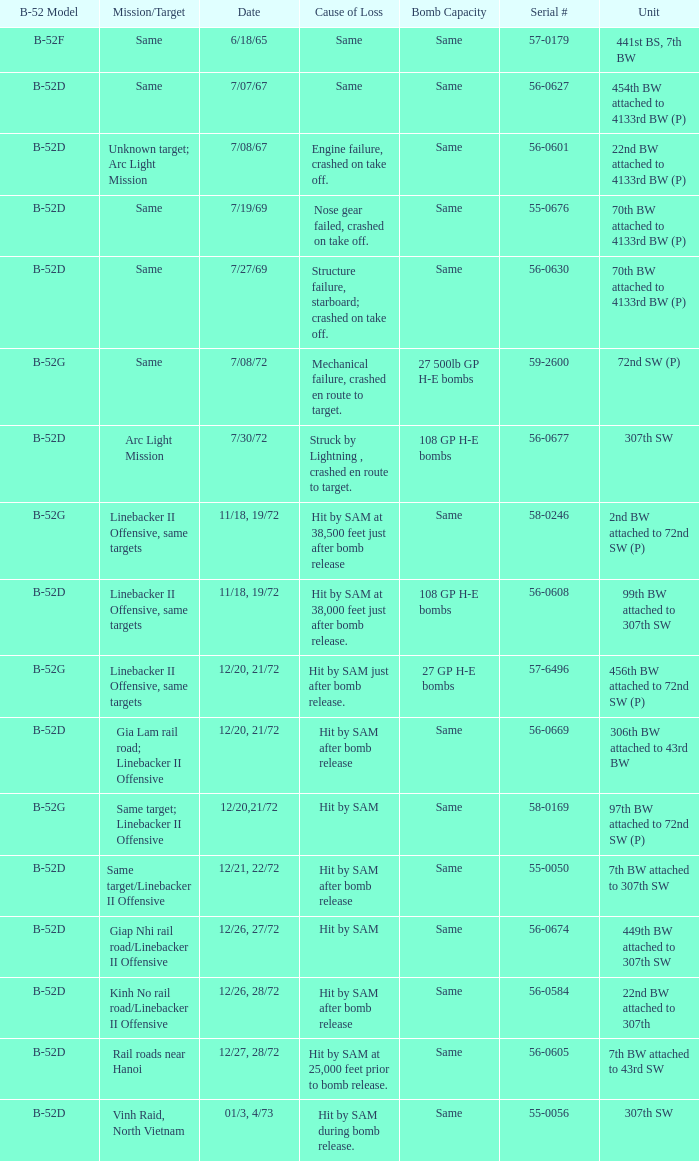When 7th bw attached to 43rd sw is the unit what is the b-52 model? B-52D. 